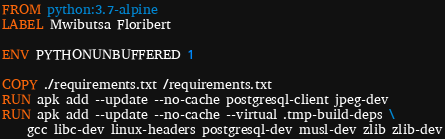<code> <loc_0><loc_0><loc_500><loc_500><_Dockerfile_>FROM python:3.7-alpine
LABEL Mwibutsa Floribert

ENV PYTHONUNBUFFERED 1

COPY ./requirements.txt /requirements.txt
RUN apk add --update --no-cache postgresql-client jpeg-dev
RUN apk add --update --no-cache --virtual .tmp-build-deps \
    gcc libc-dev linux-headers postgresql-dev musl-dev zlib zlib-dev</code> 